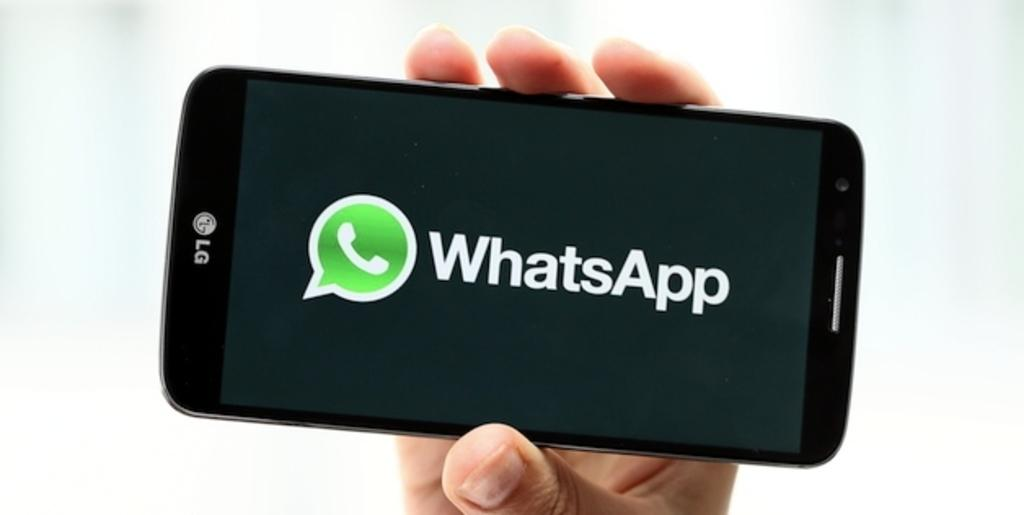What is being held by the human hand in the image? There is a human hand holding a mobile in the image. What is visible on the mobile's screen? The mobile is displaying some text. What can be seen in the background of the image? There is a plain background in the image. What type of patch is being sewn onto the kite in the image? There is no kite or patch present in the image. What is being written in the notebook in the image? There is no notebook present in the image. 